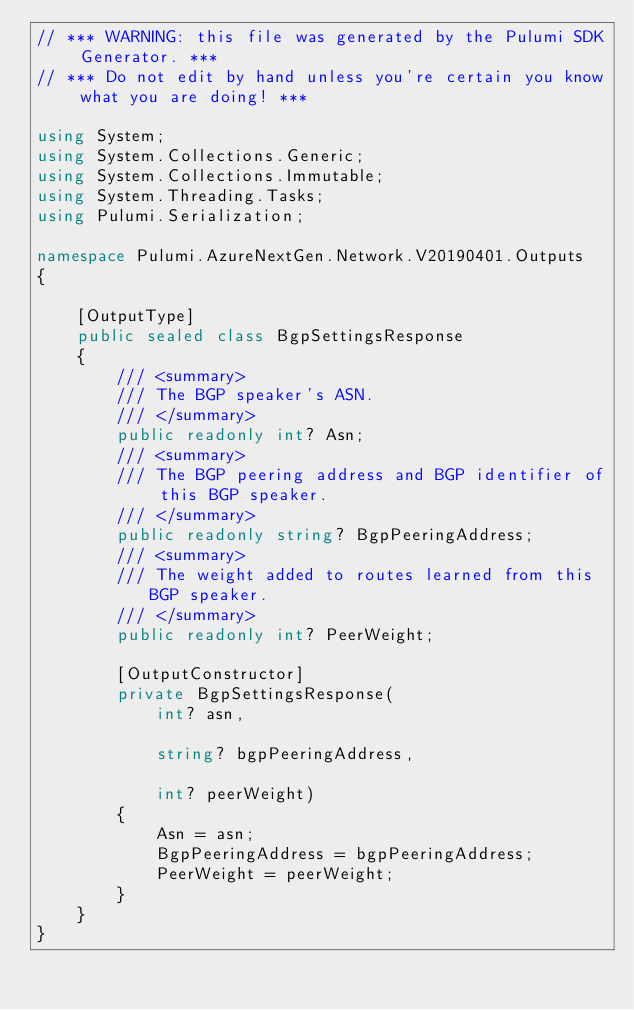Convert code to text. <code><loc_0><loc_0><loc_500><loc_500><_C#_>// *** WARNING: this file was generated by the Pulumi SDK Generator. ***
// *** Do not edit by hand unless you're certain you know what you are doing! ***

using System;
using System.Collections.Generic;
using System.Collections.Immutable;
using System.Threading.Tasks;
using Pulumi.Serialization;

namespace Pulumi.AzureNextGen.Network.V20190401.Outputs
{

    [OutputType]
    public sealed class BgpSettingsResponse
    {
        /// <summary>
        /// The BGP speaker's ASN.
        /// </summary>
        public readonly int? Asn;
        /// <summary>
        /// The BGP peering address and BGP identifier of this BGP speaker.
        /// </summary>
        public readonly string? BgpPeeringAddress;
        /// <summary>
        /// The weight added to routes learned from this BGP speaker.
        /// </summary>
        public readonly int? PeerWeight;

        [OutputConstructor]
        private BgpSettingsResponse(
            int? asn,

            string? bgpPeeringAddress,

            int? peerWeight)
        {
            Asn = asn;
            BgpPeeringAddress = bgpPeeringAddress;
            PeerWeight = peerWeight;
        }
    }
}
</code> 